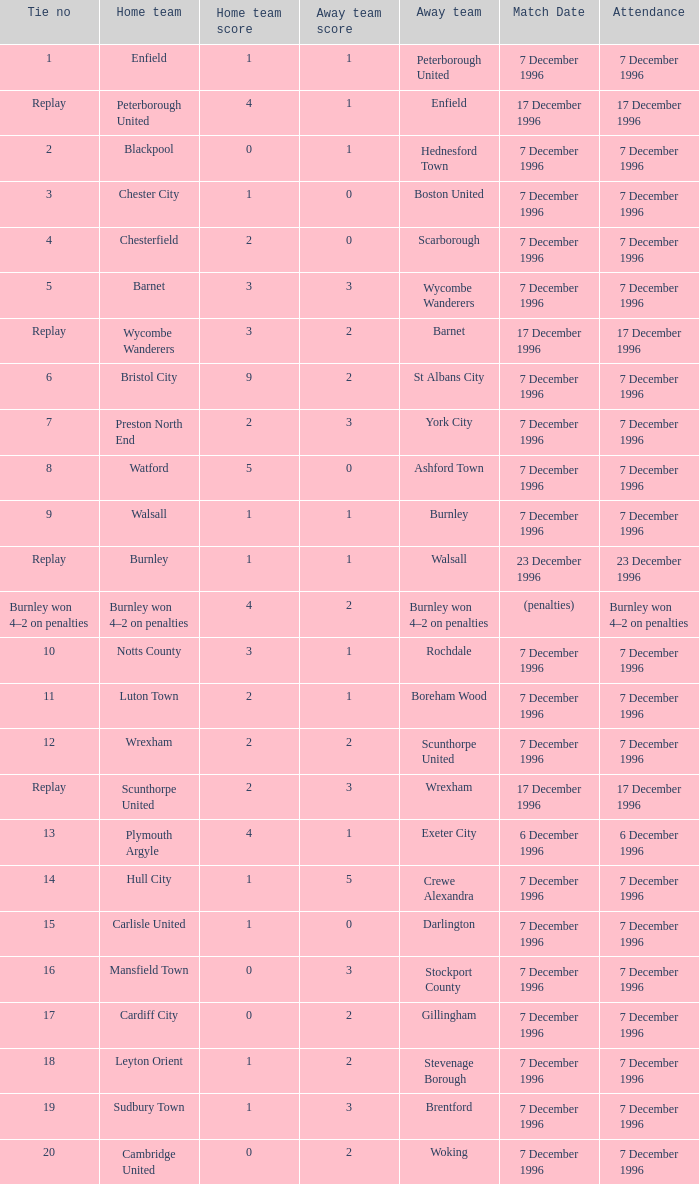Who were the away team in tie number 20? Woking. 